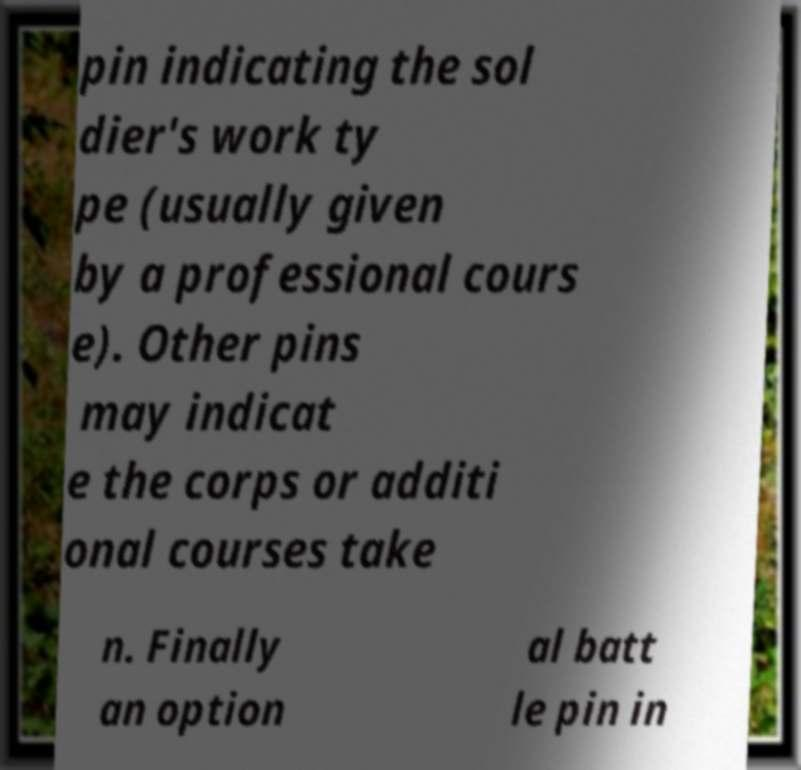For documentation purposes, I need the text within this image transcribed. Could you provide that? pin indicating the sol dier's work ty pe (usually given by a professional cours e). Other pins may indicat e the corps or additi onal courses take n. Finally an option al batt le pin in 